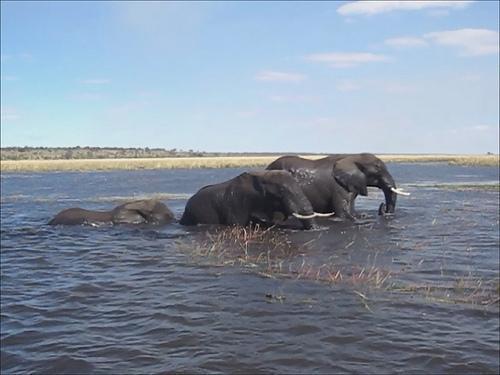How many elephants are there?
Give a very brief answer. 3. 